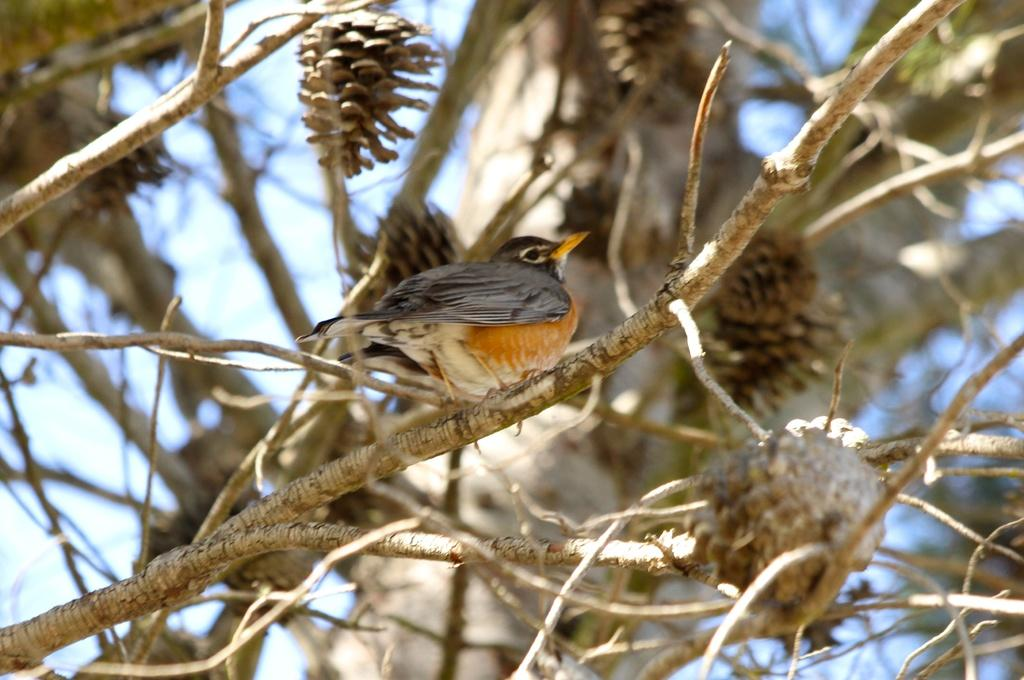What type of animal is in the image? There is a bird in the image. Where is the bird located? The bird is on a tree branch. What color is the sky in the background of the image? The sky is blue in the background of the image. What type of apparel is the bird wearing in the image? Birds do not wear apparel, so there is no clothing visible in the image. What kind of breakfast is the bird eating in the image? The bird is not eating breakfast in the image; it is perched on a tree branch. 